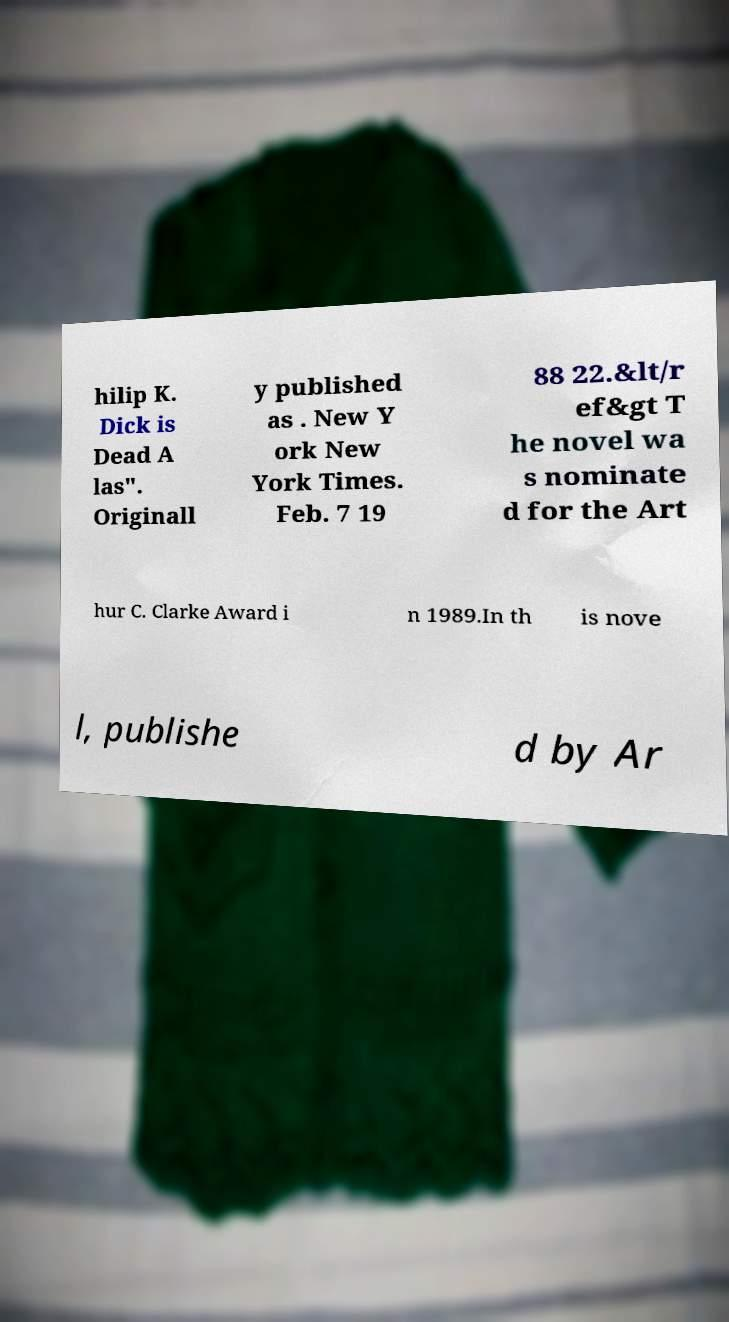There's text embedded in this image that I need extracted. Can you transcribe it verbatim? hilip K. Dick is Dead A las". Originall y published as . New Y ork New York Times. Feb. 7 19 88 22.&lt/r ef&gt T he novel wa s nominate d for the Art hur C. Clarke Award i n 1989.In th is nove l, publishe d by Ar 